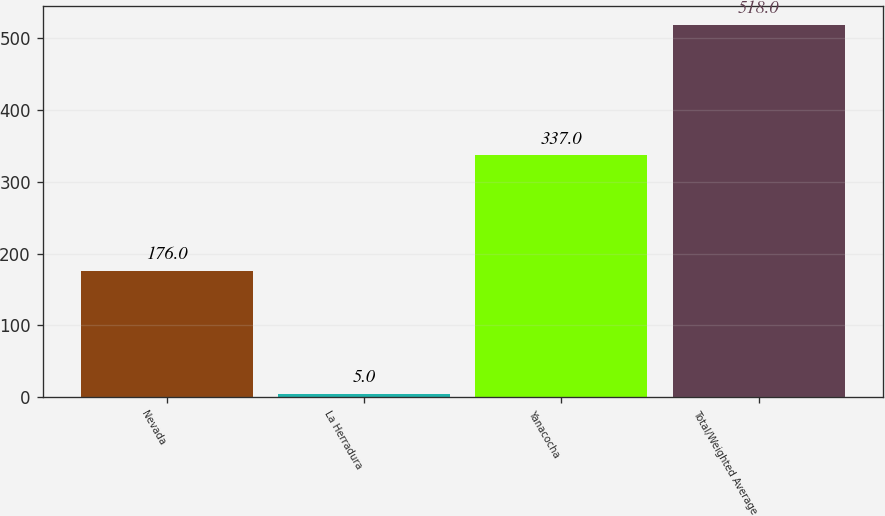Convert chart to OTSL. <chart><loc_0><loc_0><loc_500><loc_500><bar_chart><fcel>Nevada<fcel>La Herradura<fcel>Yanacocha<fcel>Total/Weighted Average<nl><fcel>176<fcel>5<fcel>337<fcel>518<nl></chart> 